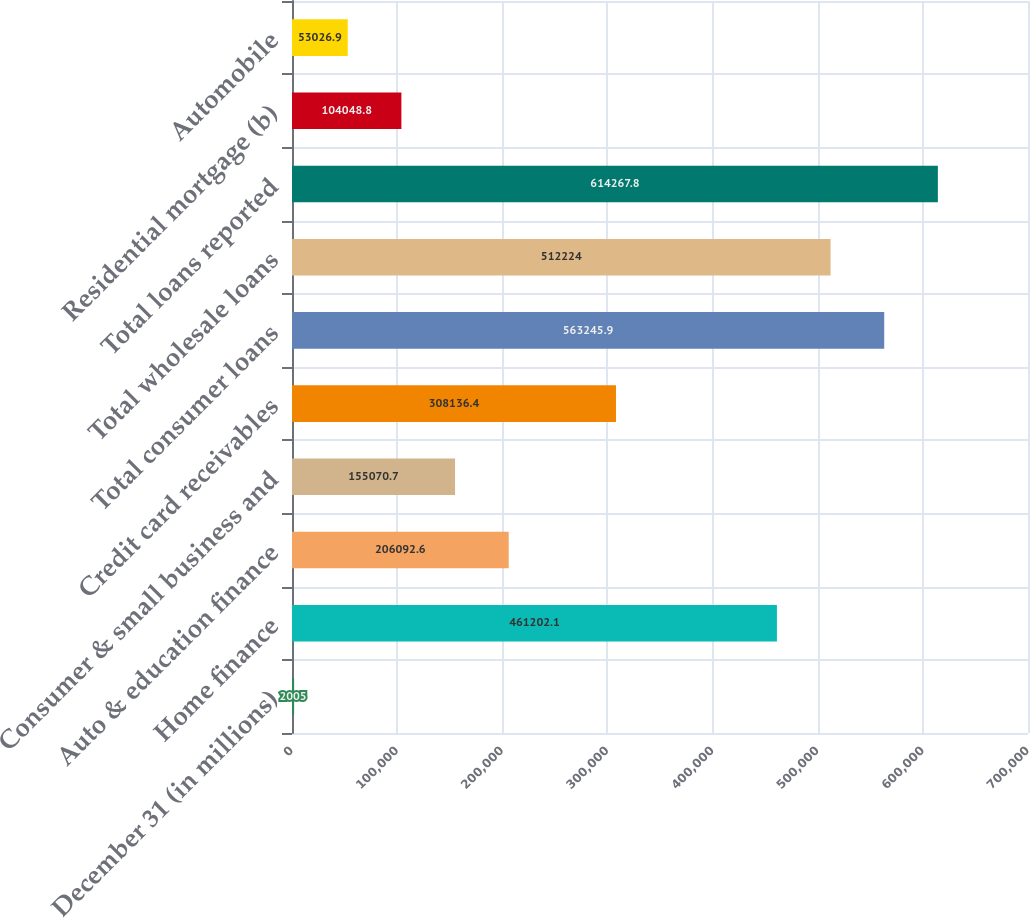<chart> <loc_0><loc_0><loc_500><loc_500><bar_chart><fcel>December 31 (in millions)<fcel>Home finance<fcel>Auto & education finance<fcel>Consumer & small business and<fcel>Credit card receivables<fcel>Total consumer loans<fcel>Total wholesale loans<fcel>Total loans reported<fcel>Residential mortgage (b)<fcel>Automobile<nl><fcel>2005<fcel>461202<fcel>206093<fcel>155071<fcel>308136<fcel>563246<fcel>512224<fcel>614268<fcel>104049<fcel>53026.9<nl></chart> 